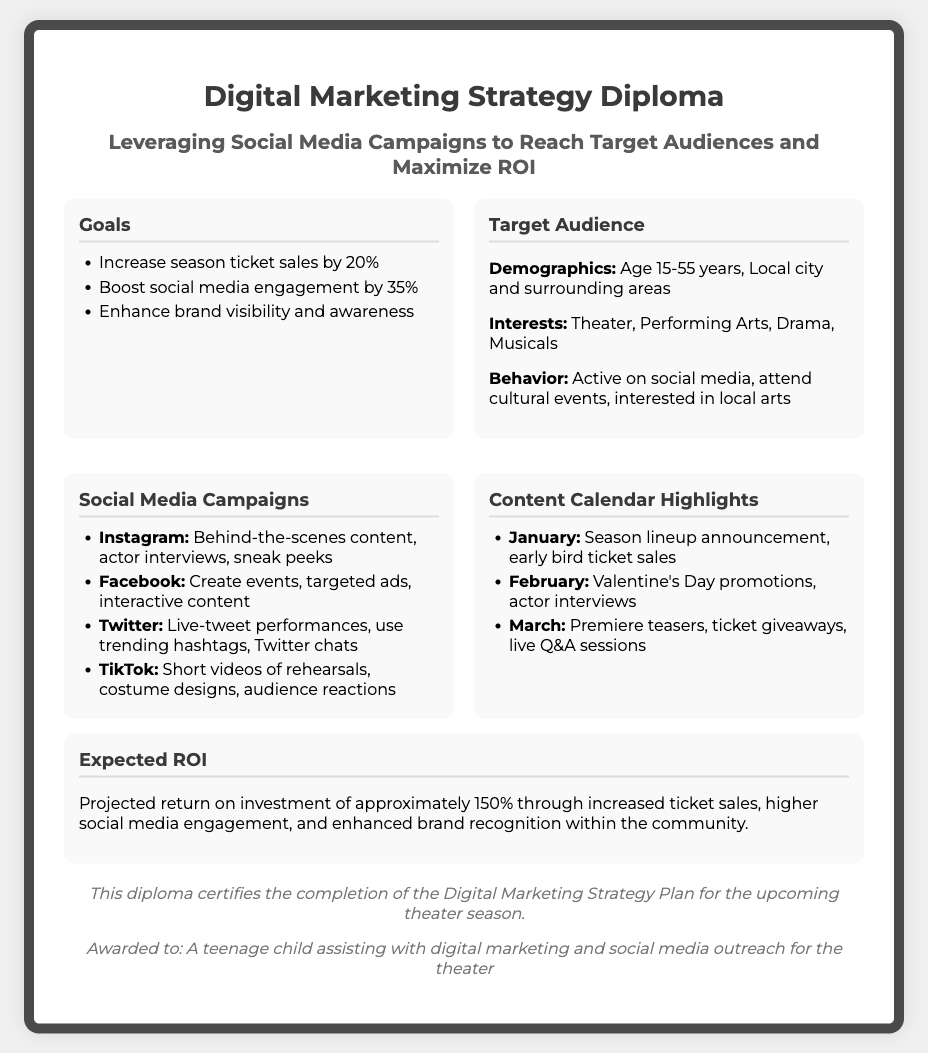what is the goal related to season ticket sales? The goal is to increase season ticket sales by 20%.
Answer: 20% who is the target audience's age range? The target audience's age range is 15-55 years.
Answer: 15-55 years what type of content will be created for Instagram? The type of content for Instagram includes behind-the-scenes content, actor interviews, and sneak peeks.
Answer: behind-the-scenes content, actor interviews, sneak peeks what is projected ROI for the marketing strategy? The projected ROI is approximately 150%.
Answer: 150% which month includes Valentine’s Day promotions? The month that includes Valentine's Day promotions is February.
Answer: February 